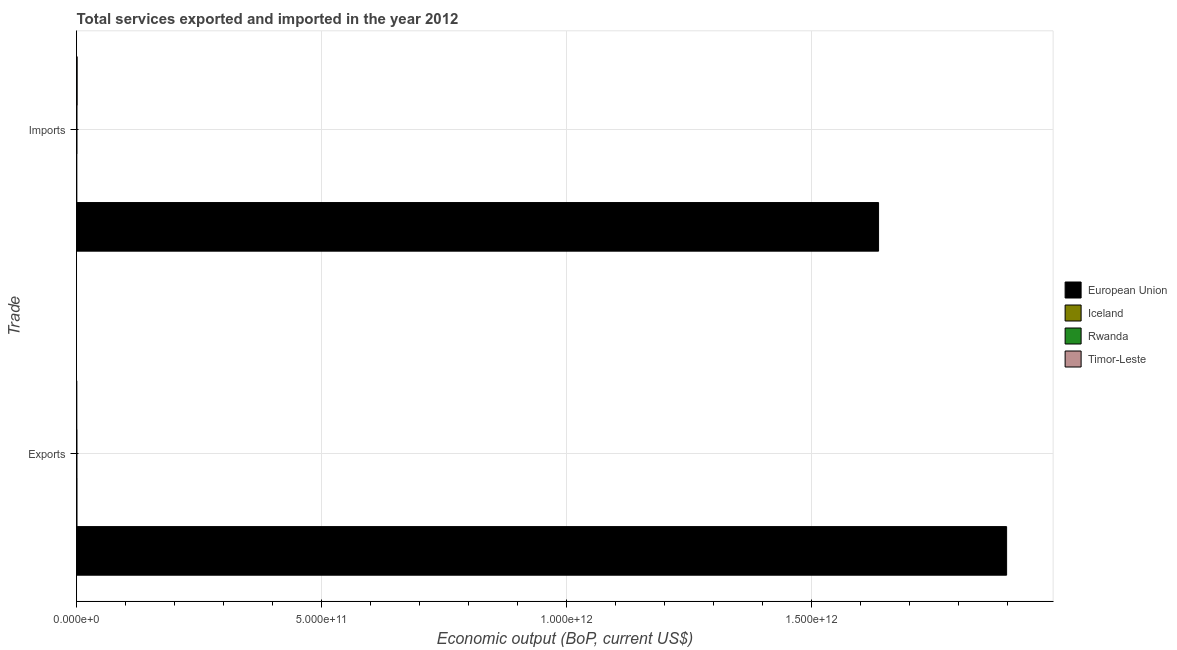How many bars are there on the 1st tick from the bottom?
Keep it short and to the point. 4. What is the label of the 2nd group of bars from the top?
Your answer should be very brief. Exports. What is the amount of service exports in Timor-Leste?
Your response must be concise. 6.94e+07. Across all countries, what is the maximum amount of service exports?
Ensure brevity in your answer.  1.90e+12. Across all countries, what is the minimum amount of service imports?
Ensure brevity in your answer.  1.18e+08. What is the total amount of service exports in the graph?
Your answer should be very brief. 1.90e+12. What is the difference between the amount of service exports in European Union and that in Iceland?
Your answer should be very brief. 1.90e+12. What is the difference between the amount of service imports in Rwanda and the amount of service exports in Timor-Leste?
Provide a short and direct response. 4.49e+08. What is the average amount of service imports per country?
Your response must be concise. 4.09e+11. What is the difference between the amount of service imports and amount of service exports in Rwanda?
Offer a terse response. 9.32e+07. In how many countries, is the amount of service imports greater than 900000000000 US$?
Ensure brevity in your answer.  1. What is the ratio of the amount of service exports in Iceland to that in Timor-Leste?
Make the answer very short. 7.87. Is the amount of service exports in Timor-Leste less than that in Iceland?
Keep it short and to the point. Yes. What does the 2nd bar from the top in Imports represents?
Provide a succinct answer. Rwanda. What does the 3rd bar from the bottom in Imports represents?
Offer a very short reply. Rwanda. How many bars are there?
Offer a very short reply. 8. Are all the bars in the graph horizontal?
Give a very brief answer. Yes. How many countries are there in the graph?
Offer a terse response. 4. What is the difference between two consecutive major ticks on the X-axis?
Offer a terse response. 5.00e+11. Are the values on the major ticks of X-axis written in scientific E-notation?
Ensure brevity in your answer.  Yes. Where does the legend appear in the graph?
Your answer should be very brief. Center right. What is the title of the graph?
Provide a short and direct response. Total services exported and imported in the year 2012. What is the label or title of the X-axis?
Your answer should be compact. Economic output (BoP, current US$). What is the label or title of the Y-axis?
Make the answer very short. Trade. What is the Economic output (BoP, current US$) of European Union in Exports?
Your answer should be compact. 1.90e+12. What is the Economic output (BoP, current US$) in Iceland in Exports?
Ensure brevity in your answer.  5.46e+08. What is the Economic output (BoP, current US$) of Rwanda in Exports?
Keep it short and to the point. 4.25e+08. What is the Economic output (BoP, current US$) in Timor-Leste in Exports?
Give a very brief answer. 6.94e+07. What is the Economic output (BoP, current US$) of European Union in Imports?
Give a very brief answer. 1.64e+12. What is the Economic output (BoP, current US$) of Iceland in Imports?
Your response must be concise. 1.18e+08. What is the Economic output (BoP, current US$) in Rwanda in Imports?
Ensure brevity in your answer.  5.19e+08. What is the Economic output (BoP, current US$) of Timor-Leste in Imports?
Offer a very short reply. 9.89e+08. Across all Trade, what is the maximum Economic output (BoP, current US$) of European Union?
Provide a short and direct response. 1.90e+12. Across all Trade, what is the maximum Economic output (BoP, current US$) of Iceland?
Provide a succinct answer. 5.46e+08. Across all Trade, what is the maximum Economic output (BoP, current US$) of Rwanda?
Keep it short and to the point. 5.19e+08. Across all Trade, what is the maximum Economic output (BoP, current US$) in Timor-Leste?
Your answer should be very brief. 9.89e+08. Across all Trade, what is the minimum Economic output (BoP, current US$) in European Union?
Ensure brevity in your answer.  1.64e+12. Across all Trade, what is the minimum Economic output (BoP, current US$) of Iceland?
Your response must be concise. 1.18e+08. Across all Trade, what is the minimum Economic output (BoP, current US$) of Rwanda?
Provide a short and direct response. 4.25e+08. Across all Trade, what is the minimum Economic output (BoP, current US$) of Timor-Leste?
Provide a succinct answer. 6.94e+07. What is the total Economic output (BoP, current US$) in European Union in the graph?
Give a very brief answer. 3.53e+12. What is the total Economic output (BoP, current US$) in Iceland in the graph?
Provide a short and direct response. 6.64e+08. What is the total Economic output (BoP, current US$) of Rwanda in the graph?
Provide a short and direct response. 9.44e+08. What is the total Economic output (BoP, current US$) of Timor-Leste in the graph?
Your answer should be compact. 1.06e+09. What is the difference between the Economic output (BoP, current US$) of European Union in Exports and that in Imports?
Offer a very short reply. 2.61e+11. What is the difference between the Economic output (BoP, current US$) of Iceland in Exports and that in Imports?
Your response must be concise. 4.28e+08. What is the difference between the Economic output (BoP, current US$) in Rwanda in Exports and that in Imports?
Give a very brief answer. -9.32e+07. What is the difference between the Economic output (BoP, current US$) of Timor-Leste in Exports and that in Imports?
Your response must be concise. -9.20e+08. What is the difference between the Economic output (BoP, current US$) in European Union in Exports and the Economic output (BoP, current US$) in Iceland in Imports?
Your response must be concise. 1.90e+12. What is the difference between the Economic output (BoP, current US$) of European Union in Exports and the Economic output (BoP, current US$) of Rwanda in Imports?
Provide a succinct answer. 1.90e+12. What is the difference between the Economic output (BoP, current US$) in European Union in Exports and the Economic output (BoP, current US$) in Timor-Leste in Imports?
Give a very brief answer. 1.90e+12. What is the difference between the Economic output (BoP, current US$) in Iceland in Exports and the Economic output (BoP, current US$) in Rwanda in Imports?
Offer a very short reply. 2.76e+07. What is the difference between the Economic output (BoP, current US$) in Iceland in Exports and the Economic output (BoP, current US$) in Timor-Leste in Imports?
Offer a very short reply. -4.43e+08. What is the difference between the Economic output (BoP, current US$) of Rwanda in Exports and the Economic output (BoP, current US$) of Timor-Leste in Imports?
Your response must be concise. -5.64e+08. What is the average Economic output (BoP, current US$) in European Union per Trade?
Your answer should be very brief. 1.77e+12. What is the average Economic output (BoP, current US$) in Iceland per Trade?
Your answer should be compact. 3.32e+08. What is the average Economic output (BoP, current US$) in Rwanda per Trade?
Give a very brief answer. 4.72e+08. What is the average Economic output (BoP, current US$) of Timor-Leste per Trade?
Give a very brief answer. 5.29e+08. What is the difference between the Economic output (BoP, current US$) in European Union and Economic output (BoP, current US$) in Iceland in Exports?
Offer a very short reply. 1.90e+12. What is the difference between the Economic output (BoP, current US$) in European Union and Economic output (BoP, current US$) in Rwanda in Exports?
Ensure brevity in your answer.  1.90e+12. What is the difference between the Economic output (BoP, current US$) in European Union and Economic output (BoP, current US$) in Timor-Leste in Exports?
Give a very brief answer. 1.90e+12. What is the difference between the Economic output (BoP, current US$) in Iceland and Economic output (BoP, current US$) in Rwanda in Exports?
Ensure brevity in your answer.  1.21e+08. What is the difference between the Economic output (BoP, current US$) of Iceland and Economic output (BoP, current US$) of Timor-Leste in Exports?
Keep it short and to the point. 4.77e+08. What is the difference between the Economic output (BoP, current US$) in Rwanda and Economic output (BoP, current US$) in Timor-Leste in Exports?
Provide a short and direct response. 3.56e+08. What is the difference between the Economic output (BoP, current US$) of European Union and Economic output (BoP, current US$) of Iceland in Imports?
Offer a very short reply. 1.64e+12. What is the difference between the Economic output (BoP, current US$) of European Union and Economic output (BoP, current US$) of Rwanda in Imports?
Provide a short and direct response. 1.64e+12. What is the difference between the Economic output (BoP, current US$) of European Union and Economic output (BoP, current US$) of Timor-Leste in Imports?
Provide a short and direct response. 1.64e+12. What is the difference between the Economic output (BoP, current US$) in Iceland and Economic output (BoP, current US$) in Rwanda in Imports?
Give a very brief answer. -4.00e+08. What is the difference between the Economic output (BoP, current US$) of Iceland and Economic output (BoP, current US$) of Timor-Leste in Imports?
Your answer should be very brief. -8.71e+08. What is the difference between the Economic output (BoP, current US$) of Rwanda and Economic output (BoP, current US$) of Timor-Leste in Imports?
Your answer should be very brief. -4.71e+08. What is the ratio of the Economic output (BoP, current US$) in European Union in Exports to that in Imports?
Provide a succinct answer. 1.16. What is the ratio of the Economic output (BoP, current US$) in Iceland in Exports to that in Imports?
Your response must be concise. 4.62. What is the ratio of the Economic output (BoP, current US$) in Rwanda in Exports to that in Imports?
Provide a succinct answer. 0.82. What is the ratio of the Economic output (BoP, current US$) in Timor-Leste in Exports to that in Imports?
Your answer should be very brief. 0.07. What is the difference between the highest and the second highest Economic output (BoP, current US$) of European Union?
Make the answer very short. 2.61e+11. What is the difference between the highest and the second highest Economic output (BoP, current US$) of Iceland?
Offer a very short reply. 4.28e+08. What is the difference between the highest and the second highest Economic output (BoP, current US$) of Rwanda?
Offer a very short reply. 9.32e+07. What is the difference between the highest and the second highest Economic output (BoP, current US$) of Timor-Leste?
Offer a terse response. 9.20e+08. What is the difference between the highest and the lowest Economic output (BoP, current US$) in European Union?
Your answer should be very brief. 2.61e+11. What is the difference between the highest and the lowest Economic output (BoP, current US$) in Iceland?
Make the answer very short. 4.28e+08. What is the difference between the highest and the lowest Economic output (BoP, current US$) of Rwanda?
Your answer should be compact. 9.32e+07. What is the difference between the highest and the lowest Economic output (BoP, current US$) of Timor-Leste?
Your response must be concise. 9.20e+08. 